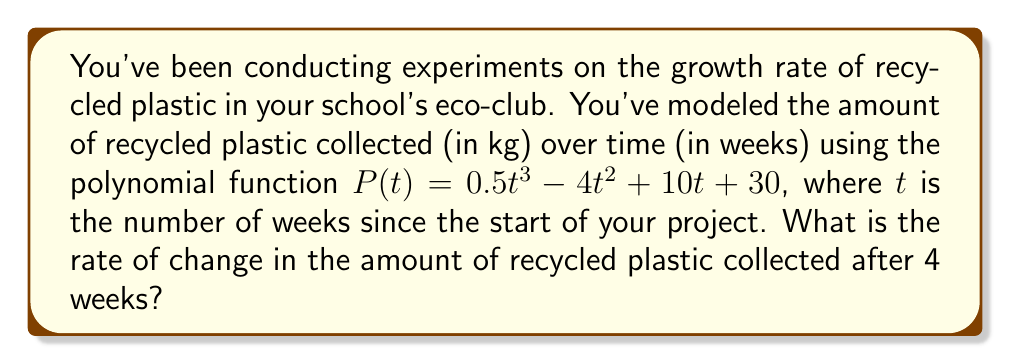Give your solution to this math problem. To find the rate of change in the amount of recycled plastic collected after 4 weeks, we need to calculate the derivative of the function $P(t)$ and evaluate it at $t = 4$. Here's how we can do this step-by-step:

1) The given function is $P(t) = 0.5t^3 - 4t^2 + 10t + 30$

2) To find the rate of change, we need to calculate $P'(t)$:
   
   $P'(t) = \frac{d}{dt}(0.5t^3 - 4t^2 + 10t + 30)$

3) Using the power rule and constant rule of differentiation:
   
   $P'(t) = 0.5 \cdot 3t^2 - 4 \cdot 2t + 10 \cdot 1 + 0$
   
   $P'(t) = 1.5t^2 - 8t + 10$

4) Now, we need to evaluate $P'(4)$:
   
   $P'(4) = 1.5(4)^2 - 8(4) + 10$
   
   $P'(4) = 1.5(16) - 32 + 10$
   
   $P'(4) = 24 - 32 + 10$
   
   $P'(4) = 2$

Therefore, after 4 weeks, the rate of change in the amount of recycled plastic collected is 2 kg/week.
Answer: 2 kg/week 